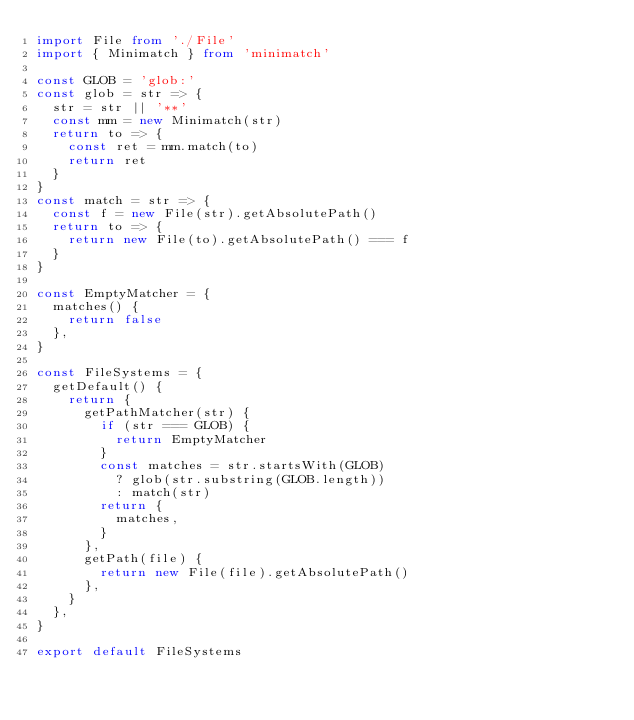<code> <loc_0><loc_0><loc_500><loc_500><_TypeScript_>import File from './File'
import { Minimatch } from 'minimatch'

const GLOB = 'glob:'
const glob = str => {
  str = str || '**'
  const mm = new Minimatch(str)
  return to => {
    const ret = mm.match(to)
    return ret
  }
}
const match = str => {
  const f = new File(str).getAbsolutePath()
  return to => {
    return new File(to).getAbsolutePath() === f
  }
}

const EmptyMatcher = {
  matches() {
    return false
  },
}

const FileSystems = {
  getDefault() {
    return {
      getPathMatcher(str) {
        if (str === GLOB) {
          return EmptyMatcher
        }
        const matches = str.startsWith(GLOB)
          ? glob(str.substring(GLOB.length))
          : match(str)
        return {
          matches,
        }
      },
      getPath(file) {
        return new File(file).getAbsolutePath()
      },
    }
  },
}

export default FileSystems
</code> 